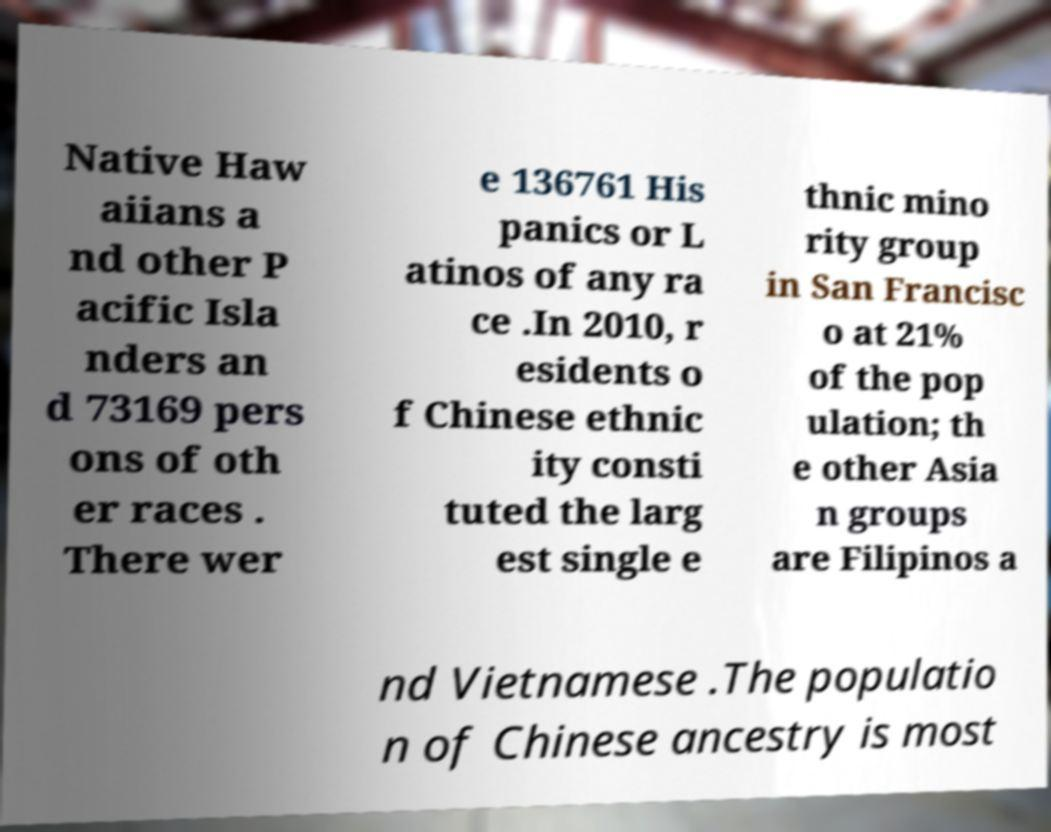I need the written content from this picture converted into text. Can you do that? Native Haw aiians a nd other P acific Isla nders an d 73169 pers ons of oth er races . There wer e 136761 His panics or L atinos of any ra ce .In 2010, r esidents o f Chinese ethnic ity consti tuted the larg est single e thnic mino rity group in San Francisc o at 21% of the pop ulation; th e other Asia n groups are Filipinos a nd Vietnamese .The populatio n of Chinese ancestry is most 